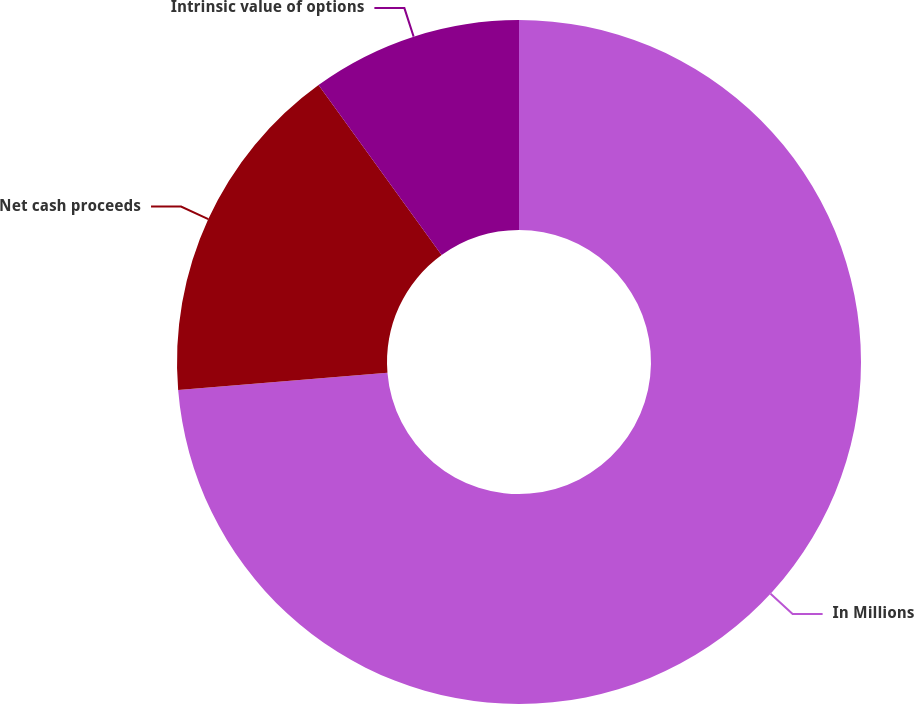Convert chart to OTSL. <chart><loc_0><loc_0><loc_500><loc_500><pie_chart><fcel>In Millions<fcel>Net cash proceeds<fcel>Intrinsic value of options<nl><fcel>73.7%<fcel>16.34%<fcel>9.97%<nl></chart> 